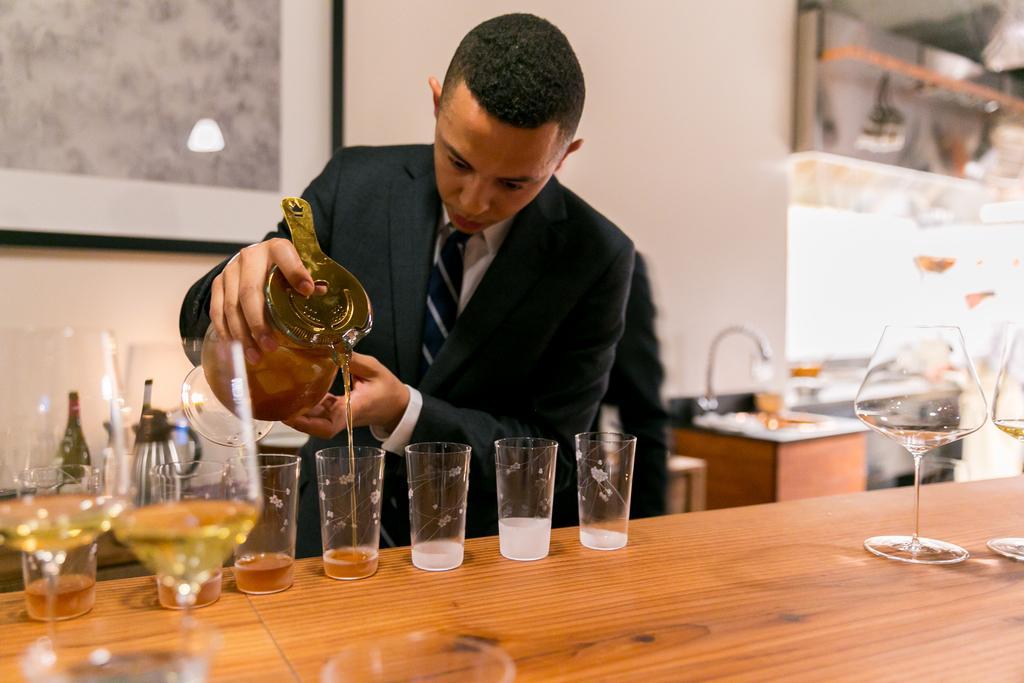In one or two sentences, can you explain what this image depicts? There are two persons in this image. The person standing in the middle wearing black suit is filling the glasses with the jar holding in his hand. In the background there is a frame, A tap. 